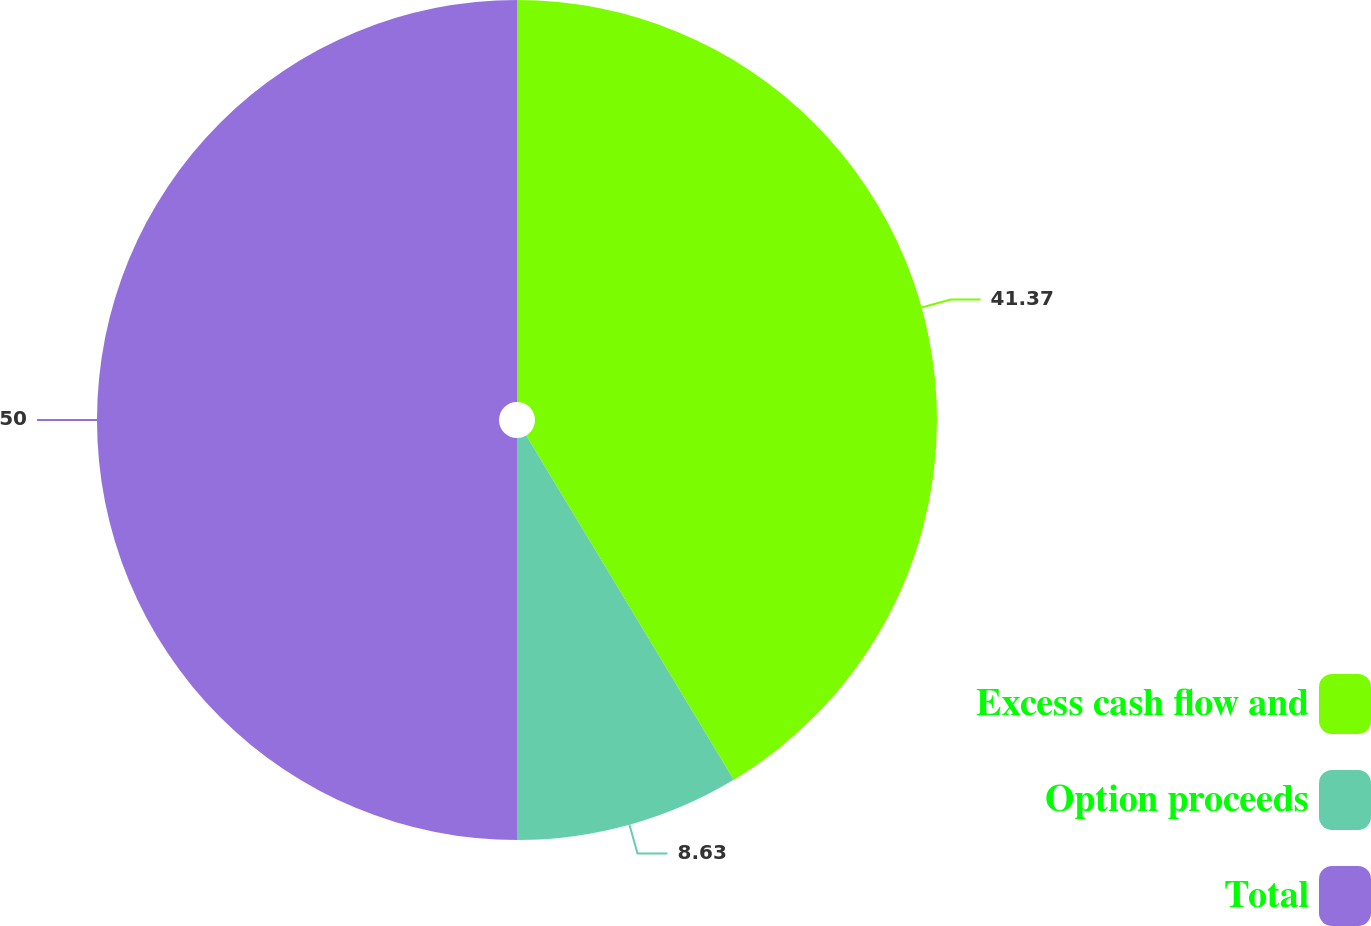Convert chart to OTSL. <chart><loc_0><loc_0><loc_500><loc_500><pie_chart><fcel>Excess cash flow and<fcel>Option proceeds<fcel>Total<nl><fcel>41.37%<fcel>8.63%<fcel>50.0%<nl></chart> 